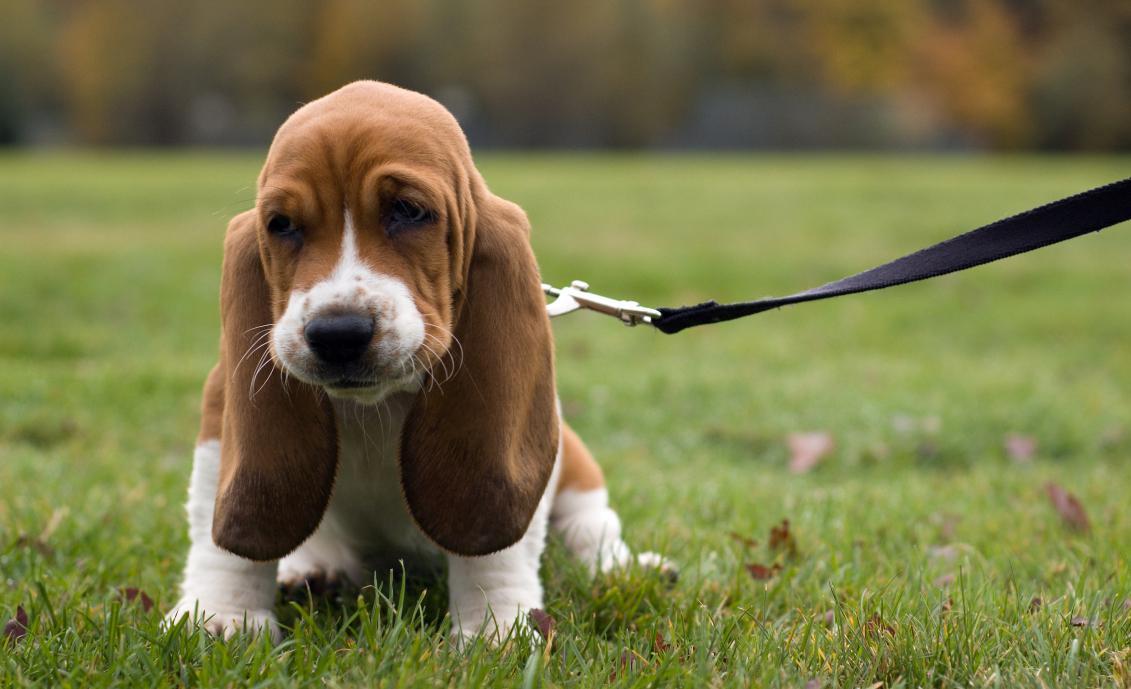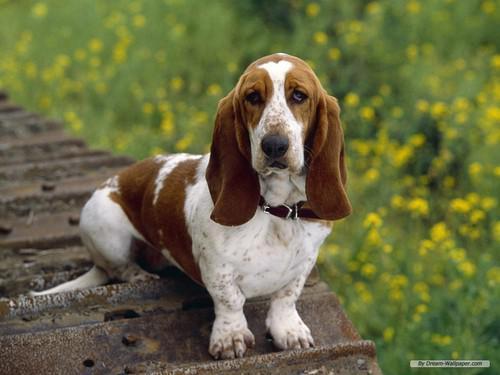The first image is the image on the left, the second image is the image on the right. For the images shown, is this caption "The dog in one of the images is running toward the camera." true? Answer yes or no. No. 